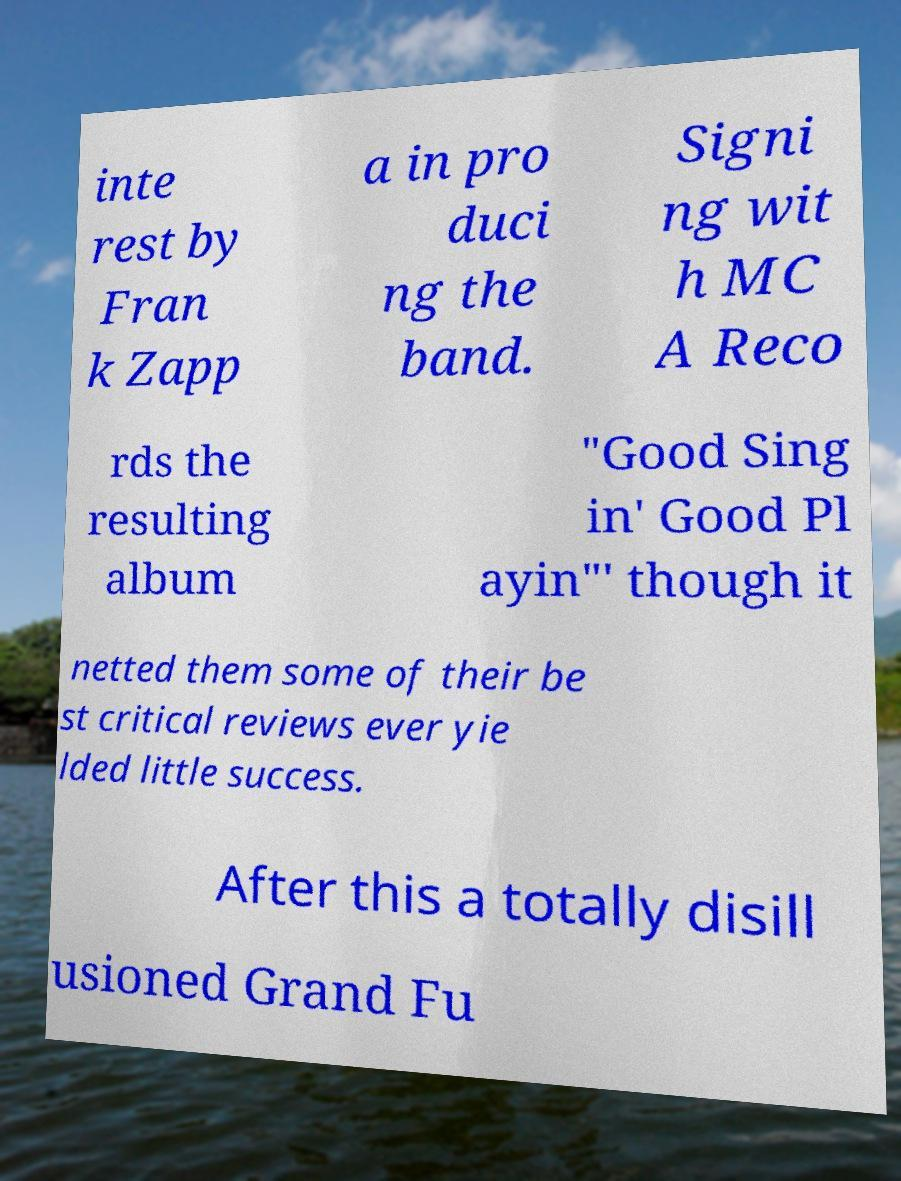For documentation purposes, I need the text within this image transcribed. Could you provide that? inte rest by Fran k Zapp a in pro duci ng the band. Signi ng wit h MC A Reco rds the resulting album "Good Sing in' Good Pl ayin"' though it netted them some of their be st critical reviews ever yie lded little success. After this a totally disill usioned Grand Fu 